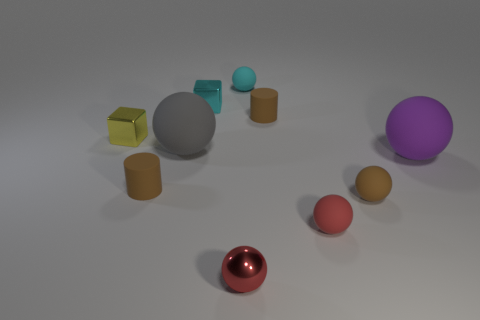There is a small sphere behind the brown ball; what is its material?
Offer a very short reply. Rubber. Are there an equal number of tiny yellow cubes that are behind the cyan rubber sphere and tiny blue cylinders?
Your answer should be compact. Yes. Is the gray rubber sphere the same size as the cyan rubber ball?
Provide a short and direct response. No. There is a purple sphere that is in front of the tiny cyan object that is left of the small shiny ball; are there any tiny brown cylinders in front of it?
Give a very brief answer. Yes. What is the material of the gray thing that is the same shape as the tiny cyan rubber object?
Provide a short and direct response. Rubber. There is a tiny brown rubber cylinder in front of the large purple rubber sphere; what number of gray balls are in front of it?
Make the answer very short. 0. There is a brown matte cylinder that is behind the block that is in front of the small brown rubber object that is behind the large gray matte ball; how big is it?
Offer a terse response. Small. There is a metallic block behind the yellow cube behind the small metal sphere; what color is it?
Your answer should be very brief. Cyan. What number of other objects are the same material as the tiny yellow cube?
Your answer should be very brief. 2. What number of other objects are there of the same color as the shiny ball?
Your response must be concise. 1. 